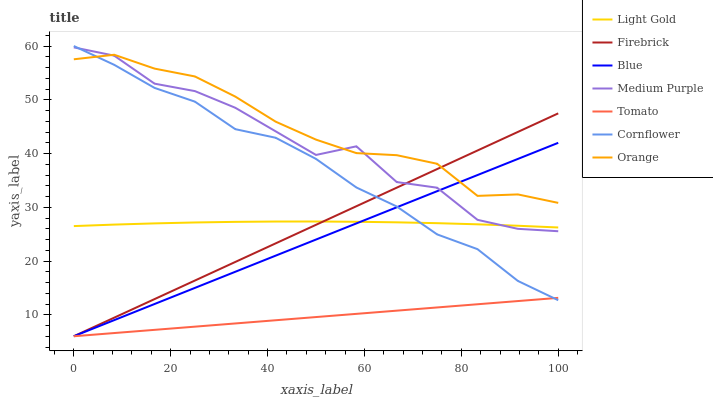Does Tomato have the minimum area under the curve?
Answer yes or no. Yes. Does Orange have the maximum area under the curve?
Answer yes or no. Yes. Does Cornflower have the minimum area under the curve?
Answer yes or no. No. Does Cornflower have the maximum area under the curve?
Answer yes or no. No. Is Tomato the smoothest?
Answer yes or no. Yes. Is Medium Purple the roughest?
Answer yes or no. Yes. Is Cornflower the smoothest?
Answer yes or no. No. Is Cornflower the roughest?
Answer yes or no. No. Does Blue have the lowest value?
Answer yes or no. Yes. Does Cornflower have the lowest value?
Answer yes or no. No. Does Cornflower have the highest value?
Answer yes or no. Yes. Does Tomato have the highest value?
Answer yes or no. No. Is Tomato less than Light Gold?
Answer yes or no. Yes. Is Orange greater than Light Gold?
Answer yes or no. Yes. Does Cornflower intersect Blue?
Answer yes or no. Yes. Is Cornflower less than Blue?
Answer yes or no. No. Is Cornflower greater than Blue?
Answer yes or no. No. Does Tomato intersect Light Gold?
Answer yes or no. No. 